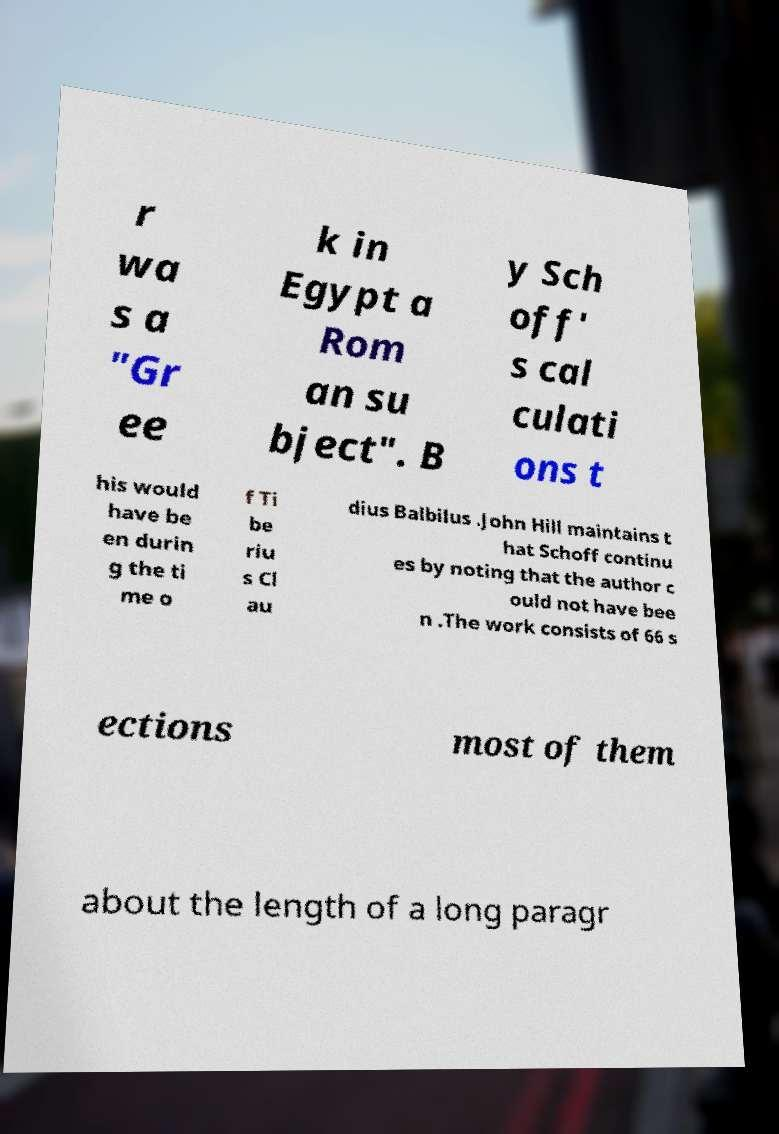Can you accurately transcribe the text from the provided image for me? r wa s a "Gr ee k in Egypt a Rom an su bject". B y Sch off' s cal culati ons t his would have be en durin g the ti me o f Ti be riu s Cl au dius Balbilus .John Hill maintains t hat Schoff continu es by noting that the author c ould not have bee n .The work consists of 66 s ections most of them about the length of a long paragr 